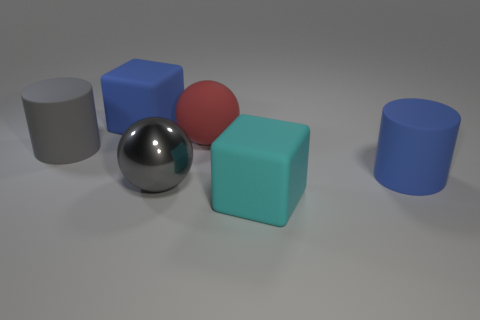Add 2 blocks. How many objects exist? 8 Subtract all gray cylinders. How many cylinders are left? 1 Subtract all cylinders. How many objects are left? 4 Subtract 2 balls. How many balls are left? 0 Subtract all red cubes. How many blue cylinders are left? 1 Add 2 cyan rubber blocks. How many cyan rubber blocks exist? 3 Subtract 0 brown balls. How many objects are left? 6 Subtract all red spheres. Subtract all red blocks. How many spheres are left? 1 Subtract all big rubber cylinders. Subtract all metal spheres. How many objects are left? 3 Add 4 blue cylinders. How many blue cylinders are left? 5 